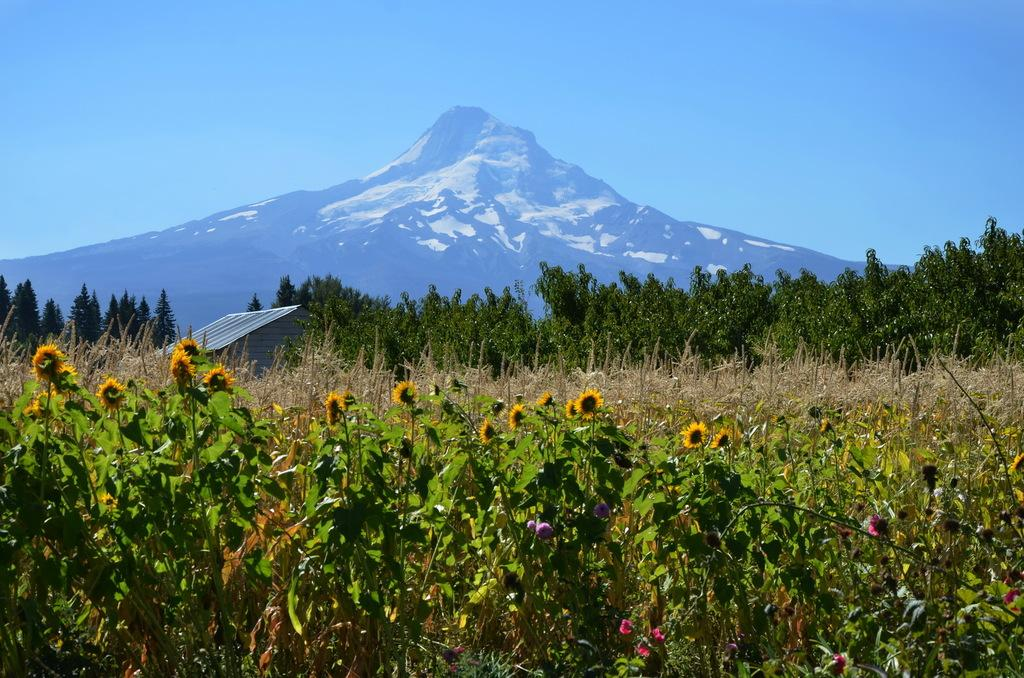What type of vegetation can be seen in the image? There are plants, trees, and flowers in the image. What type of natural landform is visible in the image? There are mountains in the image. What type of structure can be seen in the image? There is a shed in the image. What part of the natural environment is visible in the image? The sky is visible in the image. What type of ticket is required to enter the attraction in the image? There is no attraction or ticket present in the image; it features natural elements such as plants, trees, flowers, mountains, a shed, and the sky. What type of mask is being worn by the person in the image? There is no person or mask present in the image. 